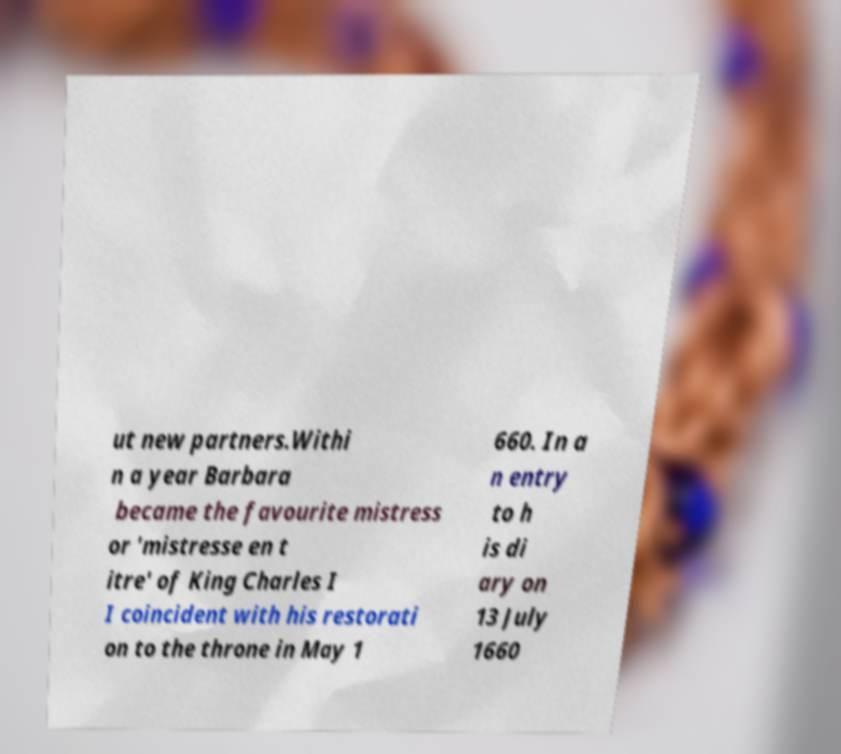Please identify and transcribe the text found in this image. ut new partners.Withi n a year Barbara became the favourite mistress or 'mistresse en t itre' of King Charles I I coincident with his restorati on to the throne in May 1 660. In a n entry to h is di ary on 13 July 1660 